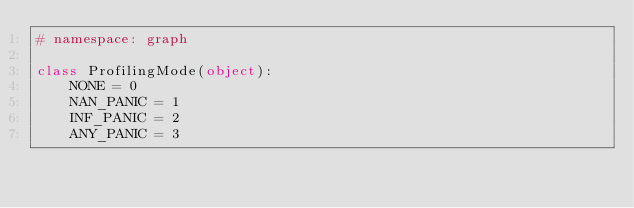Convert code to text. <code><loc_0><loc_0><loc_500><loc_500><_Python_># namespace: graph

class ProfilingMode(object):
    NONE = 0
    NAN_PANIC = 1
    INF_PANIC = 2
    ANY_PANIC = 3

</code> 